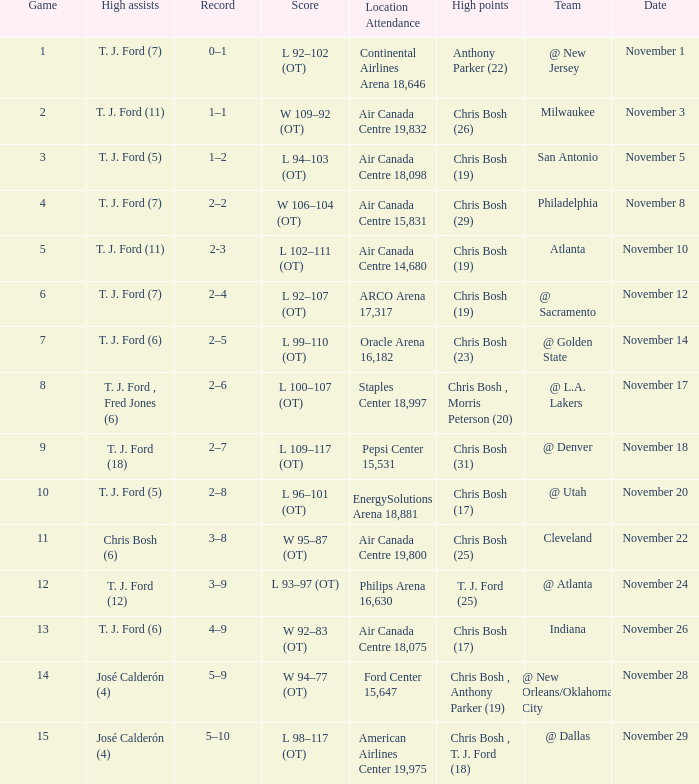What team played on November 28? @ New Orleans/Oklahoma City. 